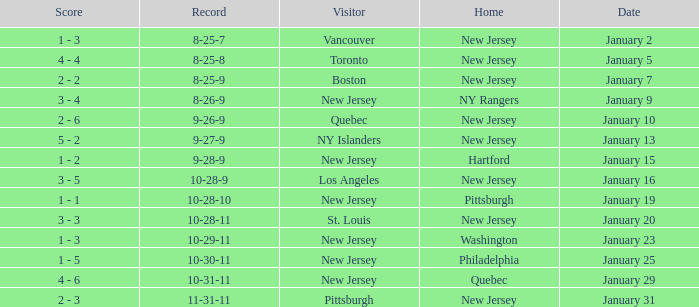What was the home team when the visiting team was Toronto? New Jersey. 